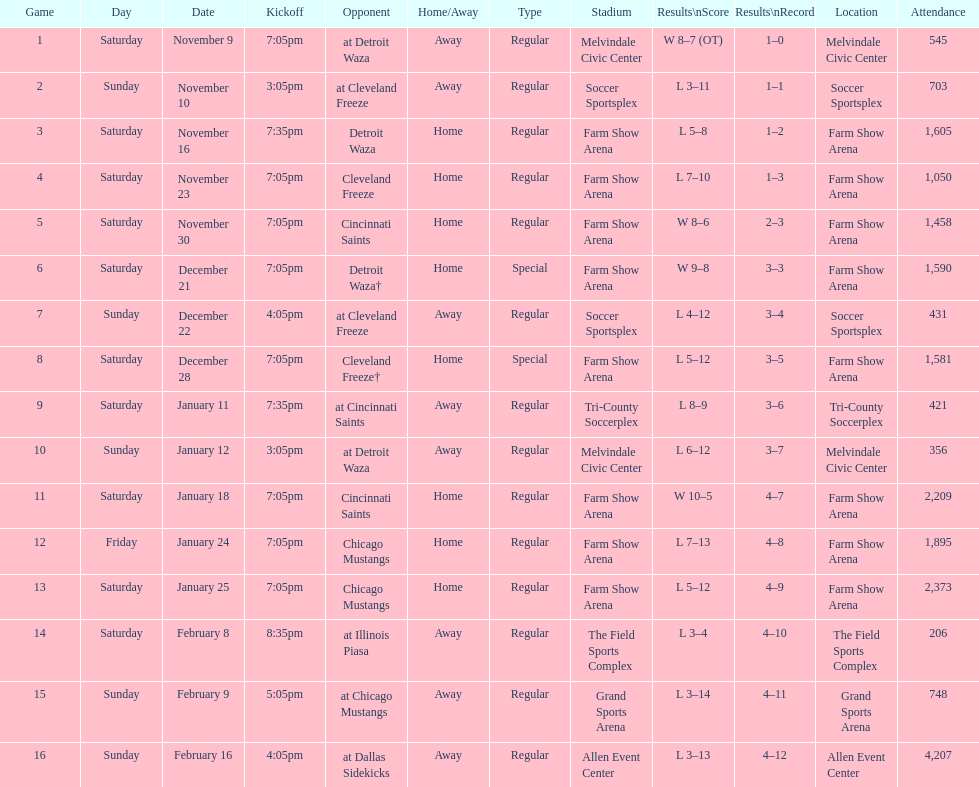Who was the first opponent on this list? Detroit Waza. 